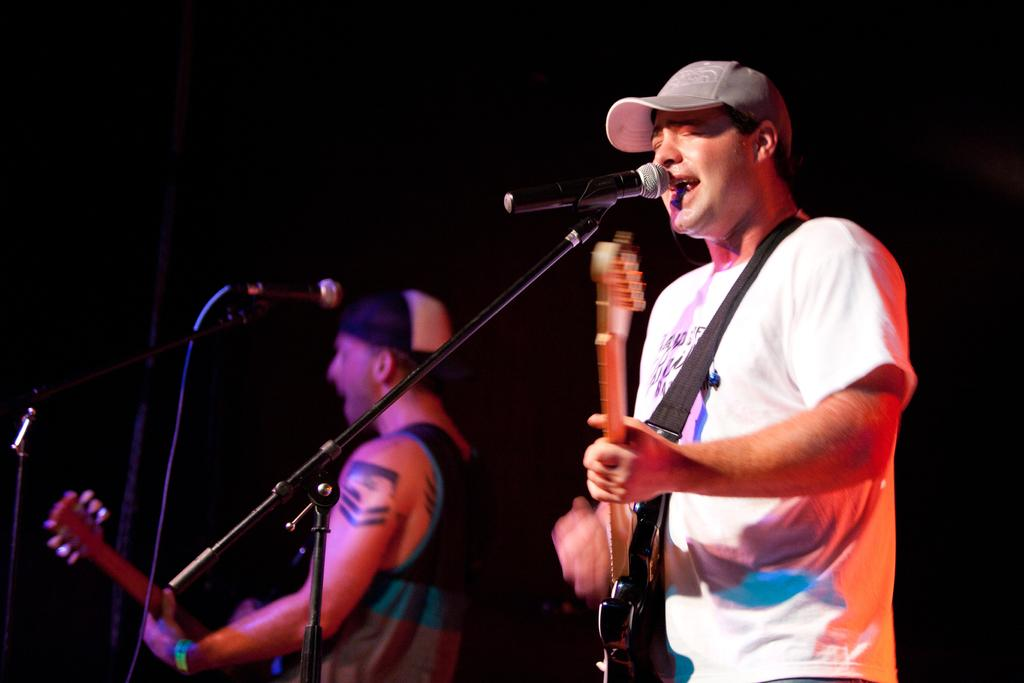How many people are in the image? There are two people in the image. What are the two people doing? The two people are playing guitars. What can be seen in the image besides the people and their guitars? There is a mic in the image, which is attached to a mike stand. What is the color of the background in the image? The background of the image is dark. Can you see any signs of destruction on the sidewalk in the image? There is no sidewalk present in the image, and therefore no signs of destruction can be observed. 